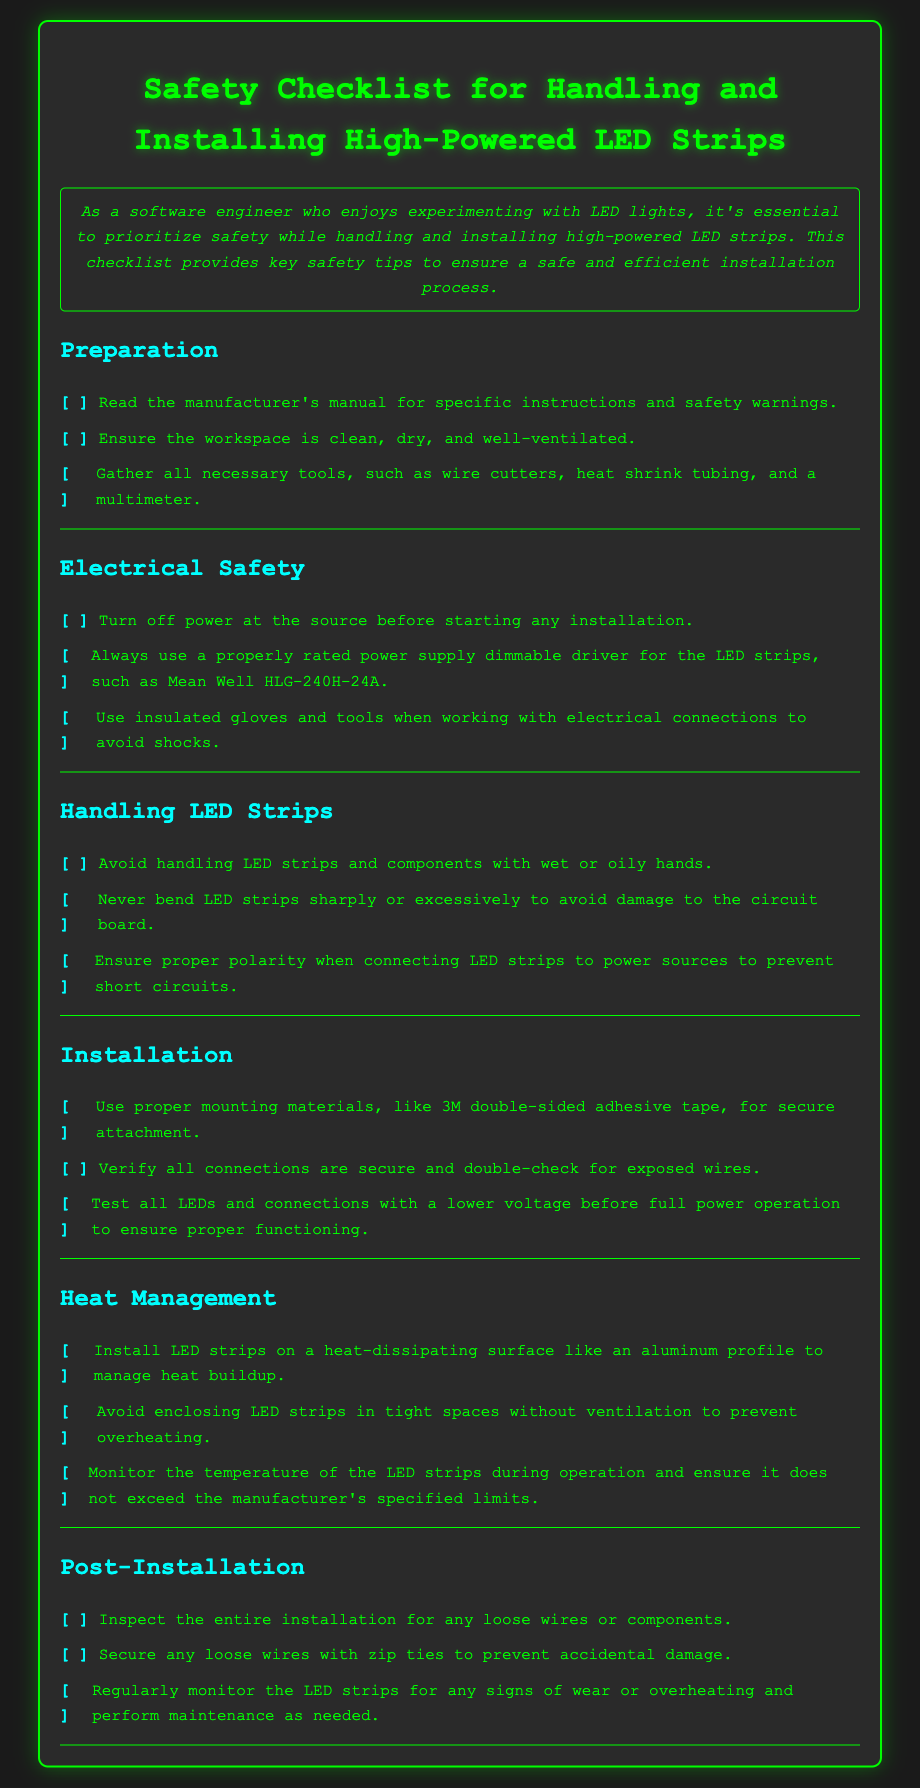What should you ensure the workspace is? The checklist specifies that the workspace should be clean, dry, and well-ventilated for safety during installation.
Answer: clean, dry, and well-ventilated What type of gloves should you use when working with electrical connections? The document states that insulated gloves should be used to avoid shocks when handling electrical connections.
Answer: insulated What is recommended to prevent overheating of LED strips? To manage heat, installing LED strips on a heat-dissipating surface like an aluminum profile is suggested.
Answer: aluminum profile How should connections be tested before full power operation? The checklist advises testing all LEDs and connections with a lower voltage to ensure proper functioning before applying full power.
Answer: lower voltage What should be used to secure loose wires? The document recommends using zip ties to secure any loose wires, preventing accidental damage.
Answer: zip ties What is the manufacturer's manual used for? According to the checklist, the manufacturer's manual should be read for specific instructions and safety warnings.
Answer: specific instructions and safety warnings What type of installation material is mentioned for secure attachment? The document mentions using 3M double-sided adhesive tape as proper mounting material for secure attachment of LED strips.
Answer: 3M double-sided adhesive tape What must you monitor during operation? The checklist indicates that monitoring the temperature of the LED strips during operation is crucial to ensure it does not exceed specified limits.
Answer: temperature 